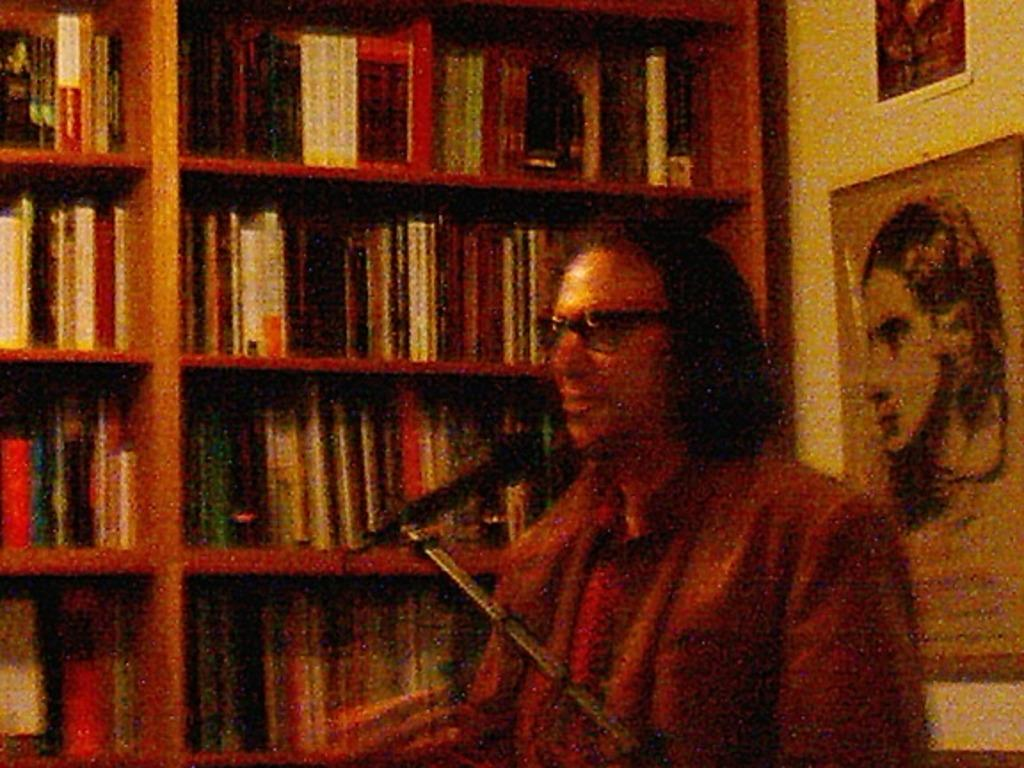<image>
Give a short and clear explanation of the subsequent image. A long-hair man is in fron of microphone with books at background 